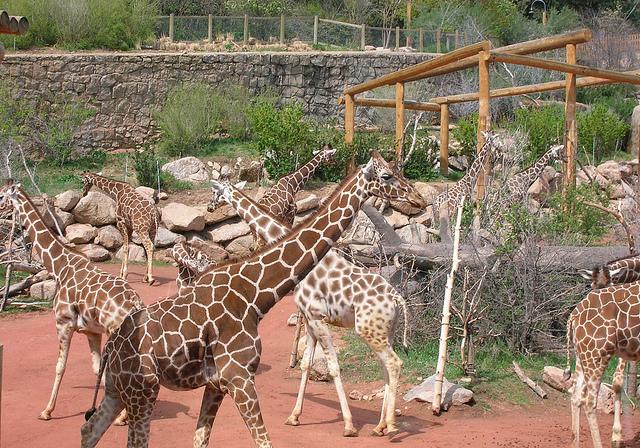How many giraffes are there?
Quick response, please. 10. What continent are these animals native to?
Give a very brief answer. Africa. How many of the giraffes are facing the right side?
Be succinct. 3. Are the giraffes in an enclosure?
Keep it brief. Yes. 